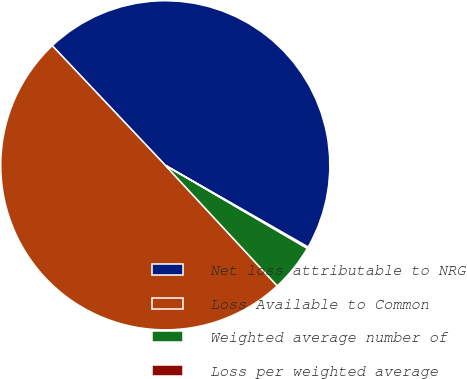Convert chart. <chart><loc_0><loc_0><loc_500><loc_500><pie_chart><fcel>Net loss attributable to NRG<fcel>Loss Available to Common<fcel>Weighted average number of<fcel>Loss per weighted average<nl><fcel>45.33%<fcel>49.86%<fcel>4.67%<fcel>0.14%<nl></chart> 